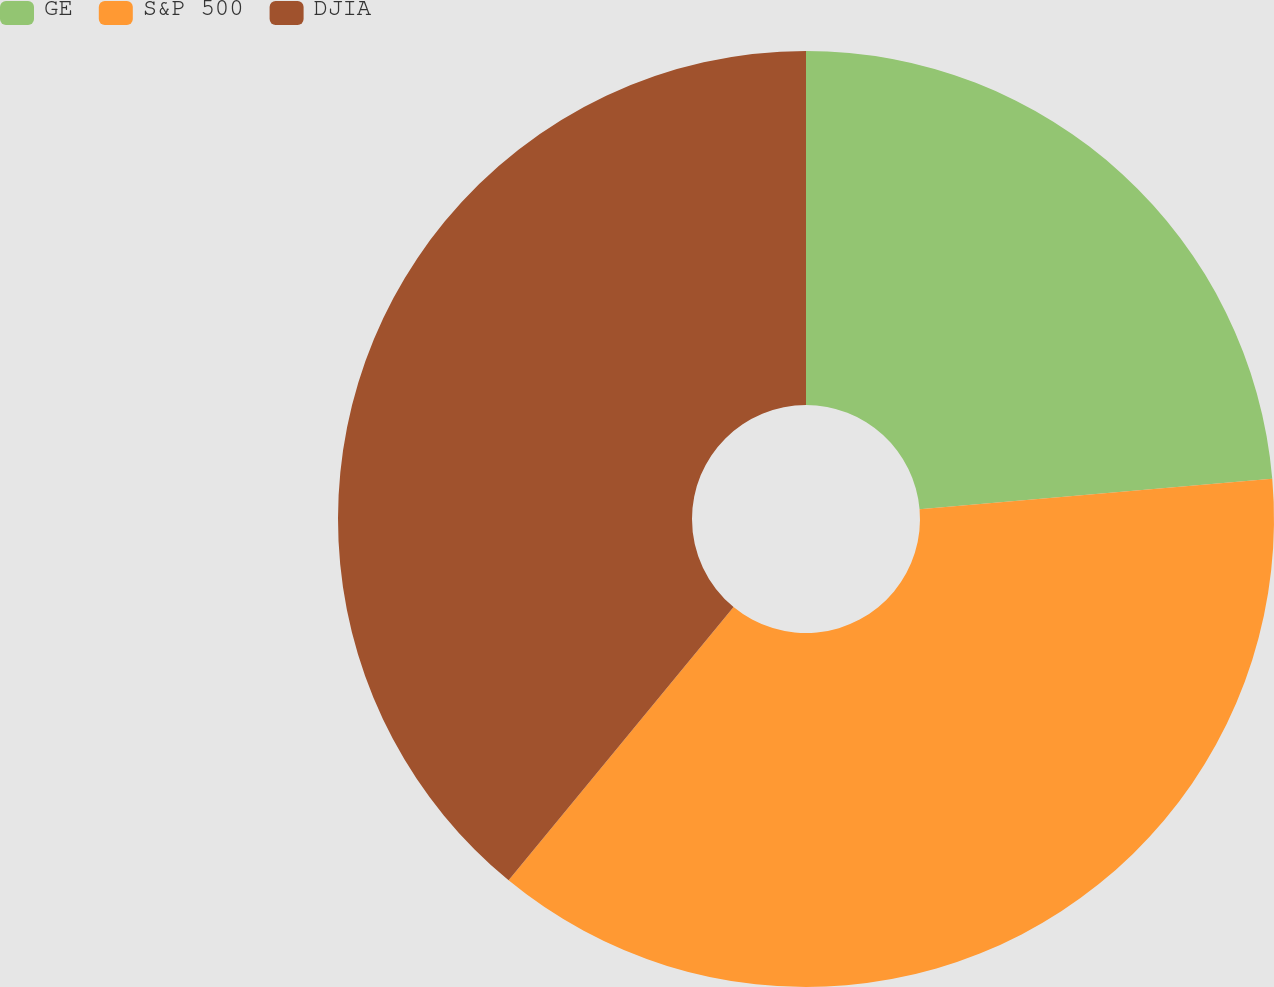<chart> <loc_0><loc_0><loc_500><loc_500><pie_chart><fcel>GE<fcel>S&P 500<fcel>DJIA<nl><fcel>23.63%<fcel>37.33%<fcel>39.04%<nl></chart> 